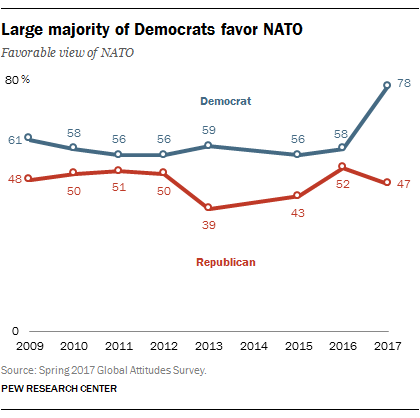Specify some key components in this picture. The difference between the blue and red graph was minimum in the year 2011. The peak value for the blue graph occurred in the year 2017. 